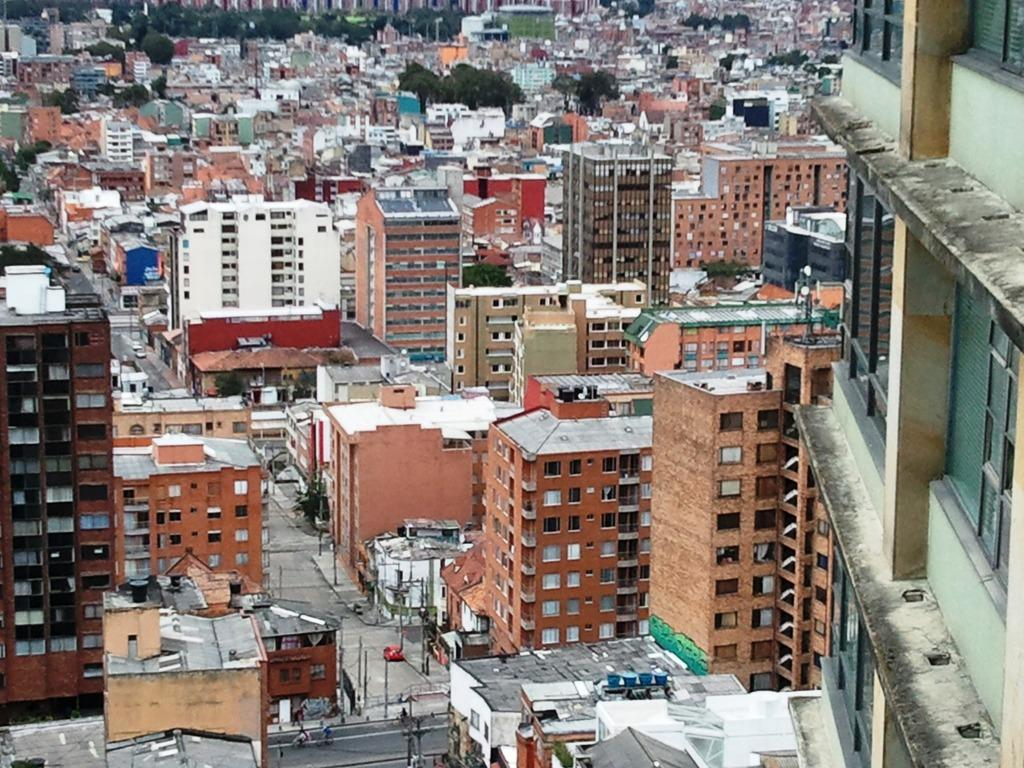What type of structures can be seen in the image? There are buildings in the image. What natural elements are visible in the image? There are trees visible in the image. Where are the vehicles located in the image? The vehicles are on the left side of the image. How many straws are being used by the snakes in the image? There are no snakes or straws present in the image. 